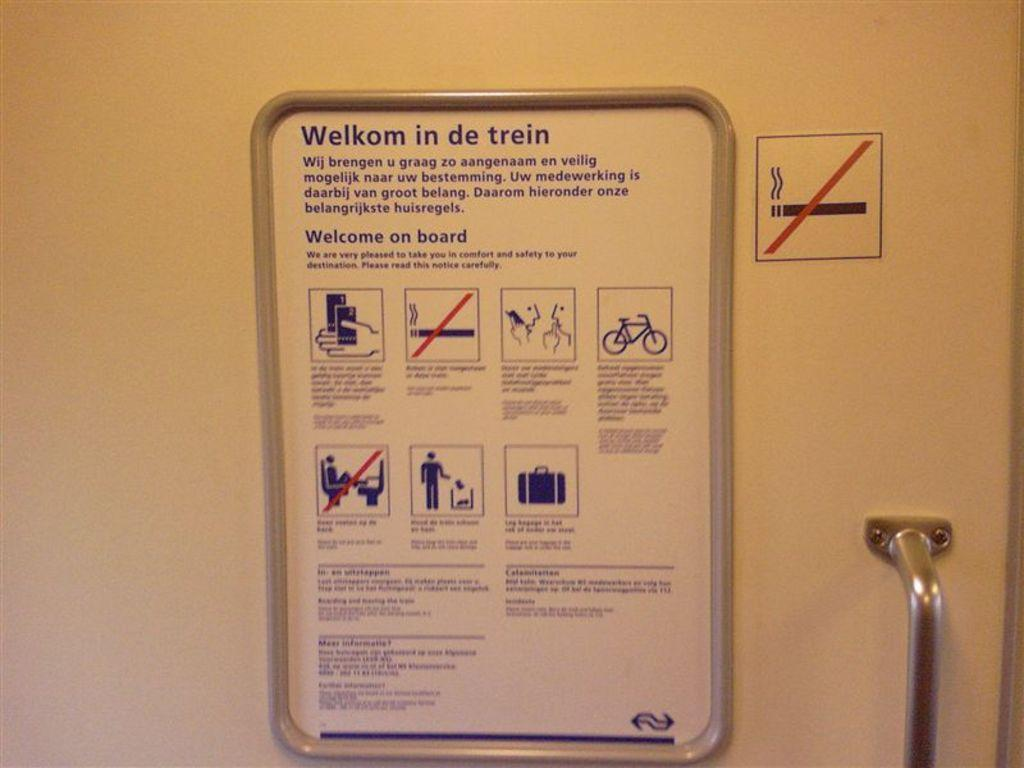What is the main object in the image? There is a door in the image. What is on the door? There is a chart and a sign on the door. What is happening to the door in the image? The door is being handled, presumably by someone. What type of scale is used to weigh the door in the image? There is no scale present in the image, and the door is not being weighed. 